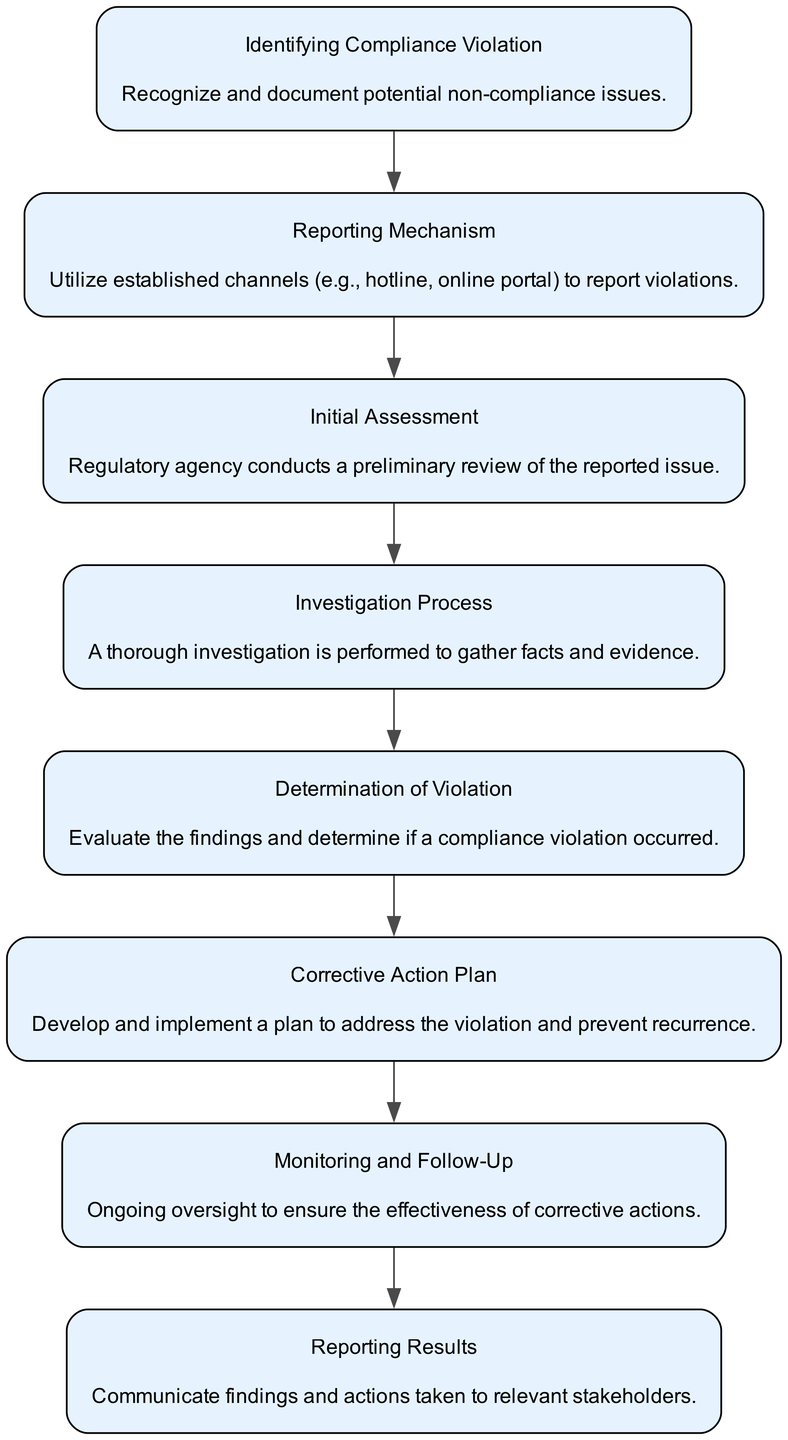What is the first step in the flow? The first step in the flow is "Identifying Compliance Violation," which signifies the initial action taken to recognize and document potential compliance issues.
Answer: Identifying Compliance Violation How many nodes are in the diagram? There are a total of eight nodes in the diagram, each representing a distinct step in the process of reporting and addressing compliance violations.
Answer: 8 What follows "Initial Assessment" in the flow? Following "Initial Assessment," the next step in the flow is the "Investigation Process," which indicates the action taken after an initial review of the reported issue.
Answer: Investigation Process Which step comes after "Determination of Violation"? The step that comes after "Determination of Violation" is "Corrective Action Plan," showing the progression from evaluating findings to addressing the violation.
Answer: Corrective Action Plan What is the last step in the flow chart? The last step in the flow chart is "Reporting Results," which involves communicating the findings and actions taken to stakeholders.
Answer: Reporting Results What process is conducted immediately after a violation is reported? Immediately after a violation is reported, the "Initial Assessment" process is conducted by the regulatory agency to perform a preliminary review of the reported issue.
Answer: Initial Assessment How are findings communicated to relevant stakeholders? Findings are communicated to relevant stakeholders through the step called "Reporting Results," which is explicitly designated for this purpose in the process.
Answer: Reporting Results What is necessary for ongoing oversight after a corrective action plan is implemented? Necessary for ongoing oversight after a corrective action plan is implemented is "Monitoring and Follow-Up," which ensures the effectiveness of the corrective actions.
Answer: Monitoring and Follow-Up 